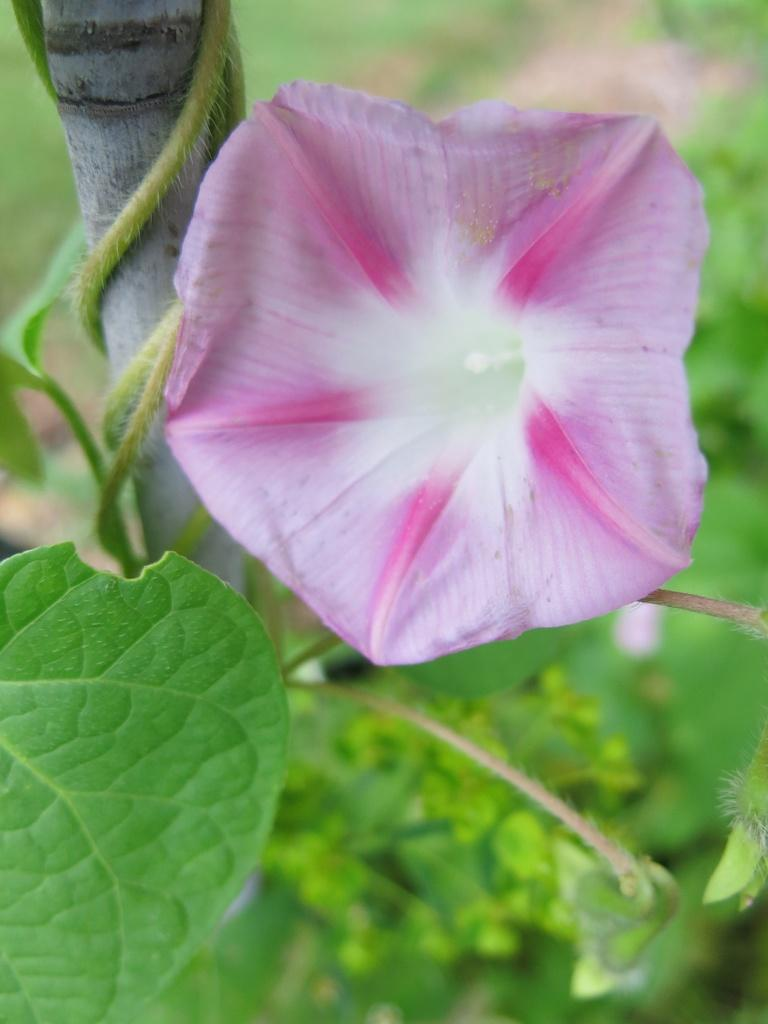What type of plant is visible in the image? There is a flower in the image, which is a type of plant. Can you describe the flower in the image? The image only shows a flower, without providing specific details about its appearance. What thought is the flower having in the image? There is no indication in the image that the flower is having any thoughts, as plants do not have the ability to think. Where is the alley located in the image? There is no alley present in the image. 